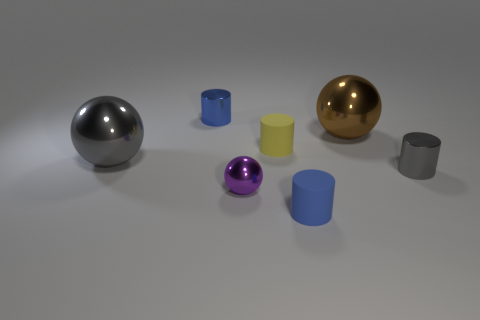Could you describe the lighting in the scene? The image features soft, diffused lighting that casts gentle shadows beneath each object, suggesting an indoor setting with a single overhead light source. Does the lighting affect the appearance of the objects? Absolutely, the lighting enhances the three-dimensionality of the objects and brings out the reflective qualities of the metallic spheres, while also highlighting the textures of the matte cylinders. 